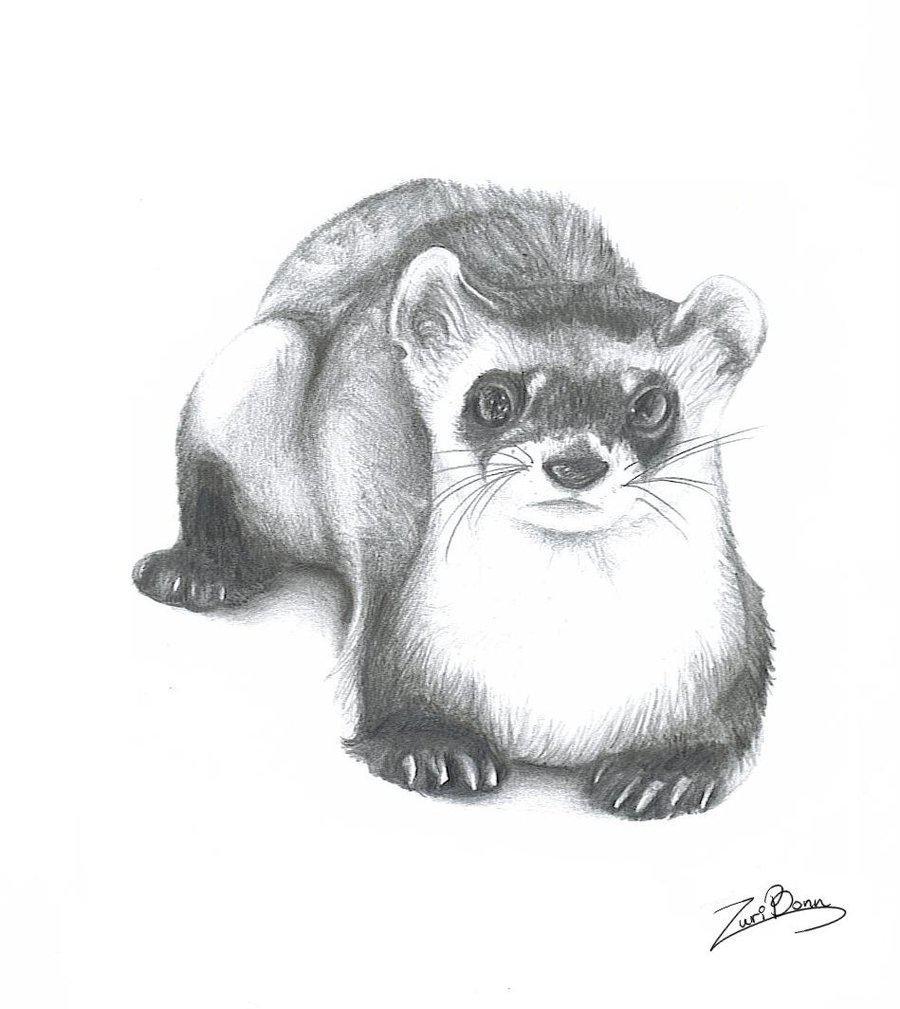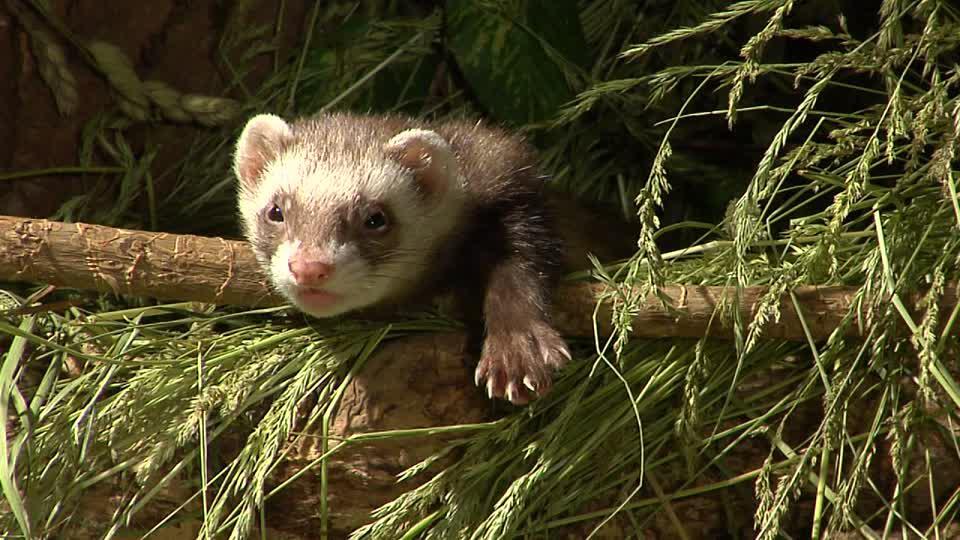The first image is the image on the left, the second image is the image on the right. Evaluate the accuracy of this statement regarding the images: "there is a ferret in tall grass". Is it true? Answer yes or no. Yes. The first image is the image on the left, the second image is the image on the right. Assess this claim about the two images: "The animal in one of the images is situated in the grass.". Correct or not? Answer yes or no. Yes. 